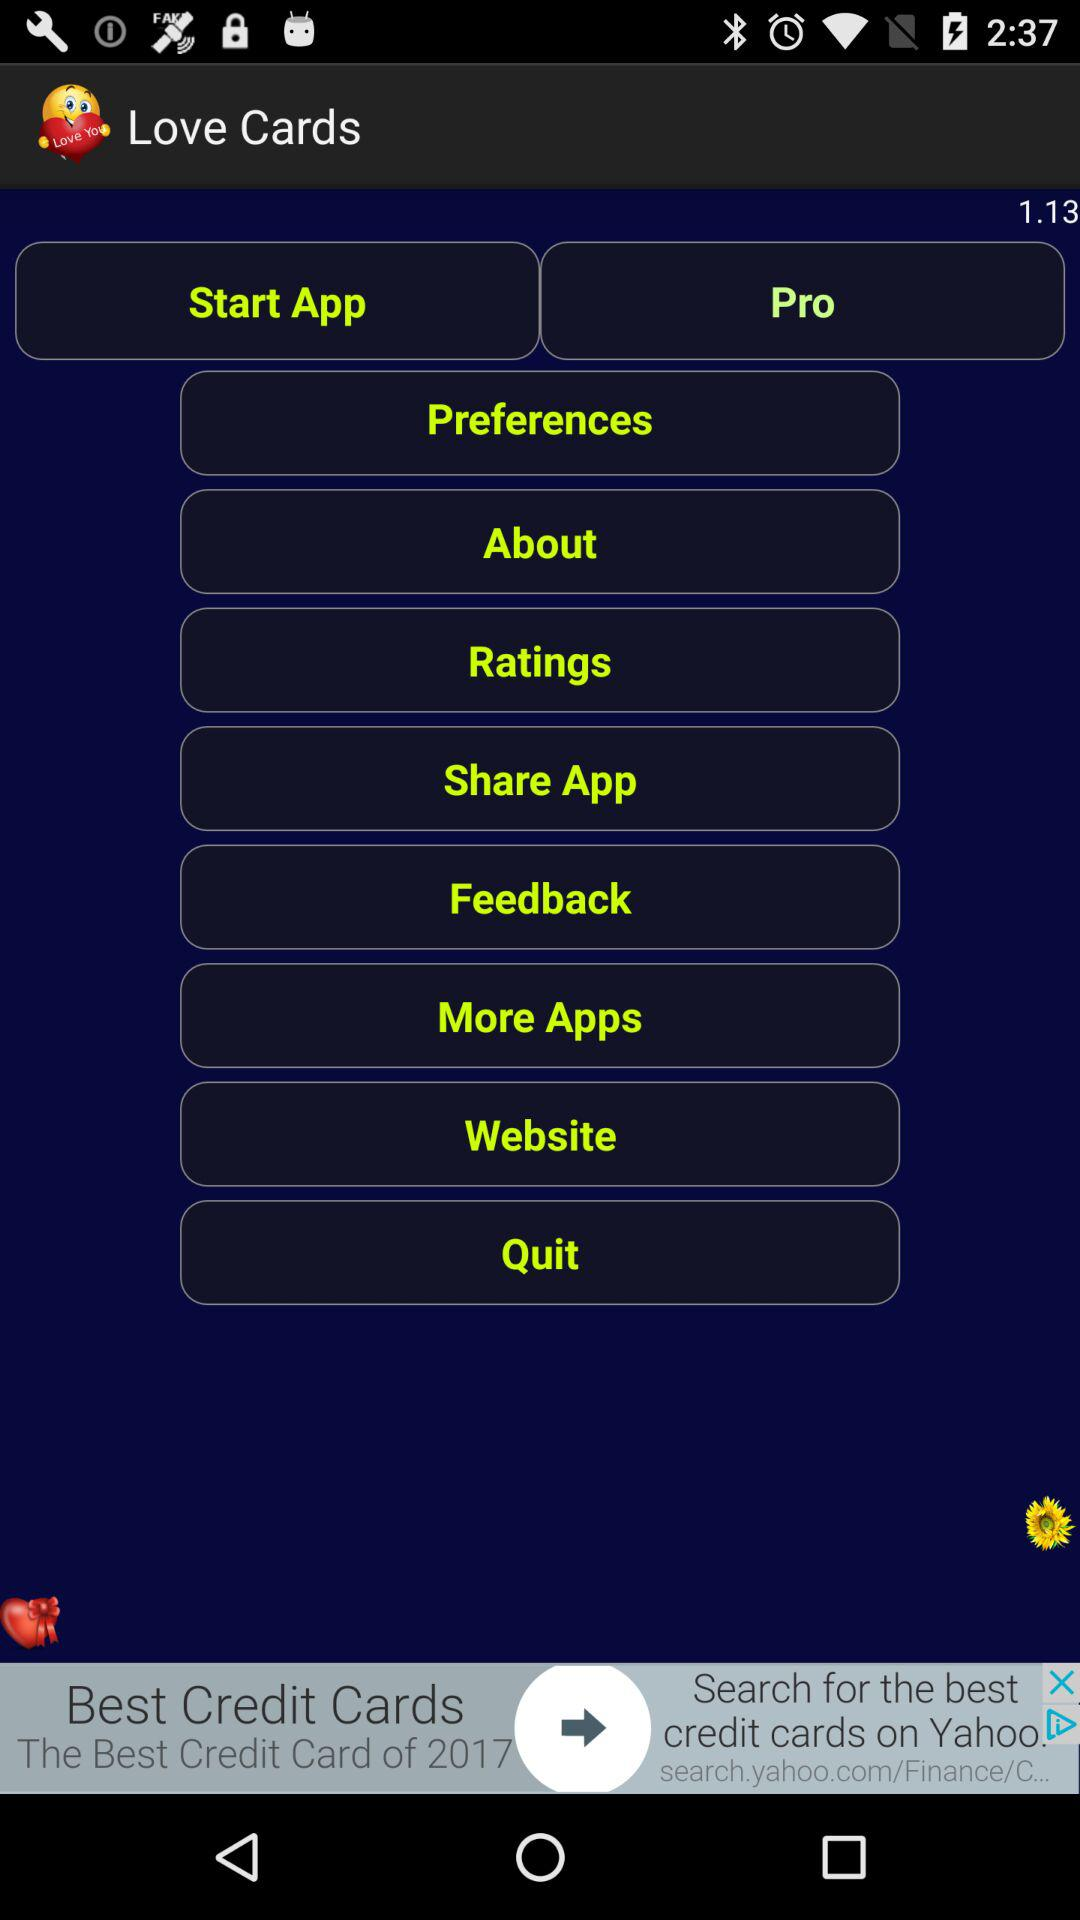What is the version of this app? The version of this application is 1.13. 